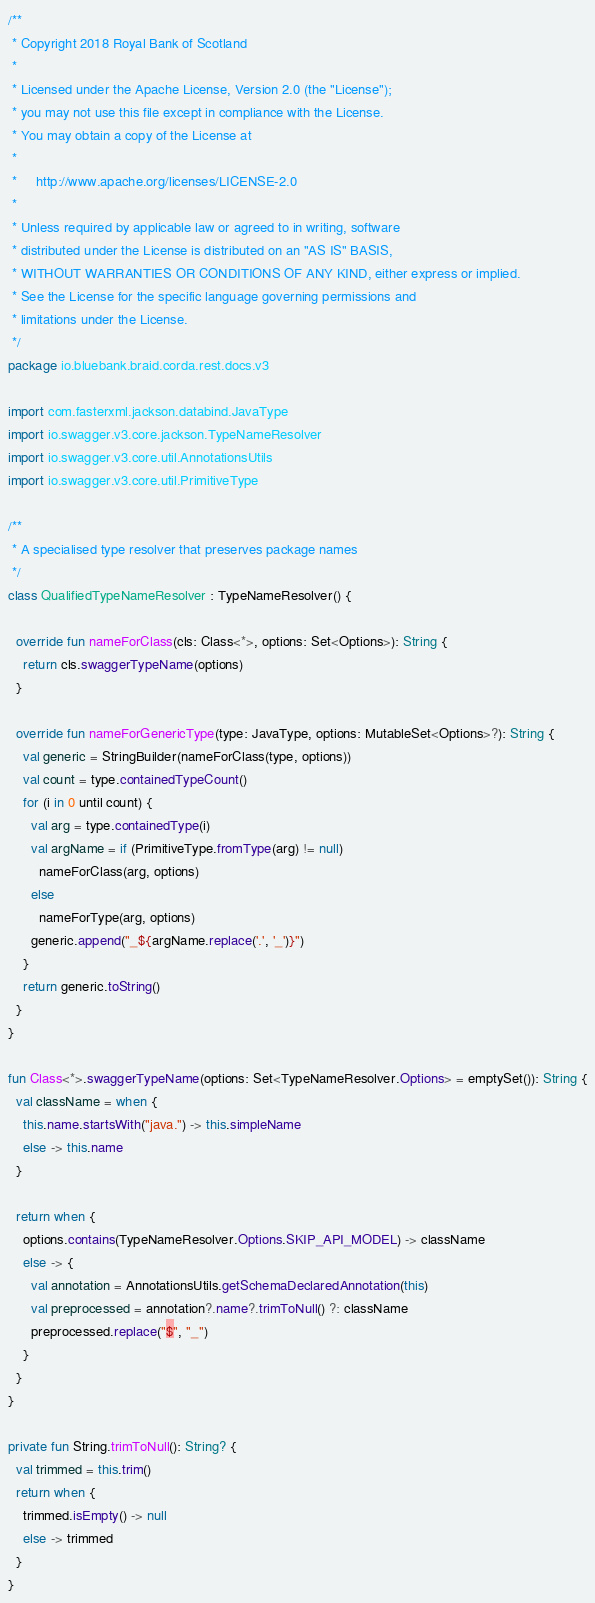Convert code to text. <code><loc_0><loc_0><loc_500><loc_500><_Kotlin_>/**
 * Copyright 2018 Royal Bank of Scotland
 *
 * Licensed under the Apache License, Version 2.0 (the "License");
 * you may not use this file except in compliance with the License.
 * You may obtain a copy of the License at
 *
 *     http://www.apache.org/licenses/LICENSE-2.0
 *
 * Unless required by applicable law or agreed to in writing, software
 * distributed under the License is distributed on an "AS IS" BASIS,
 * WITHOUT WARRANTIES OR CONDITIONS OF ANY KIND, either express or implied.
 * See the License for the specific language governing permissions and
 * limitations under the License.
 */
package io.bluebank.braid.corda.rest.docs.v3

import com.fasterxml.jackson.databind.JavaType
import io.swagger.v3.core.jackson.TypeNameResolver
import io.swagger.v3.core.util.AnnotationsUtils
import io.swagger.v3.core.util.PrimitiveType

/**
 * A specialised type resolver that preserves package names
 */
class QualifiedTypeNameResolver : TypeNameResolver() {

  override fun nameForClass(cls: Class<*>, options: Set<Options>): String {
    return cls.swaggerTypeName(options)
  }

  override fun nameForGenericType(type: JavaType, options: MutableSet<Options>?): String {
    val generic = StringBuilder(nameForClass(type, options))
    val count = type.containedTypeCount()
    for (i in 0 until count) {
      val arg = type.containedType(i)
      val argName = if (PrimitiveType.fromType(arg) != null)
        nameForClass(arg, options)
      else
        nameForType(arg, options)
      generic.append("_${argName.replace('.', '_')}")
    }
    return generic.toString()
  }
}

fun Class<*>.swaggerTypeName(options: Set<TypeNameResolver.Options> = emptySet()): String {
  val className = when {
    this.name.startsWith("java.") -> this.simpleName
    else -> this.name
  }

  return when {
    options.contains(TypeNameResolver.Options.SKIP_API_MODEL) -> className
    else -> {
      val annotation = AnnotationsUtils.getSchemaDeclaredAnnotation(this)
      val preprocessed = annotation?.name?.trimToNull() ?: className
      preprocessed.replace("$", "_")
    }
  }
}

private fun String.trimToNull(): String? {
  val trimmed = this.trim()
  return when {
    trimmed.isEmpty() -> null
    else -> trimmed
  }
}
</code> 